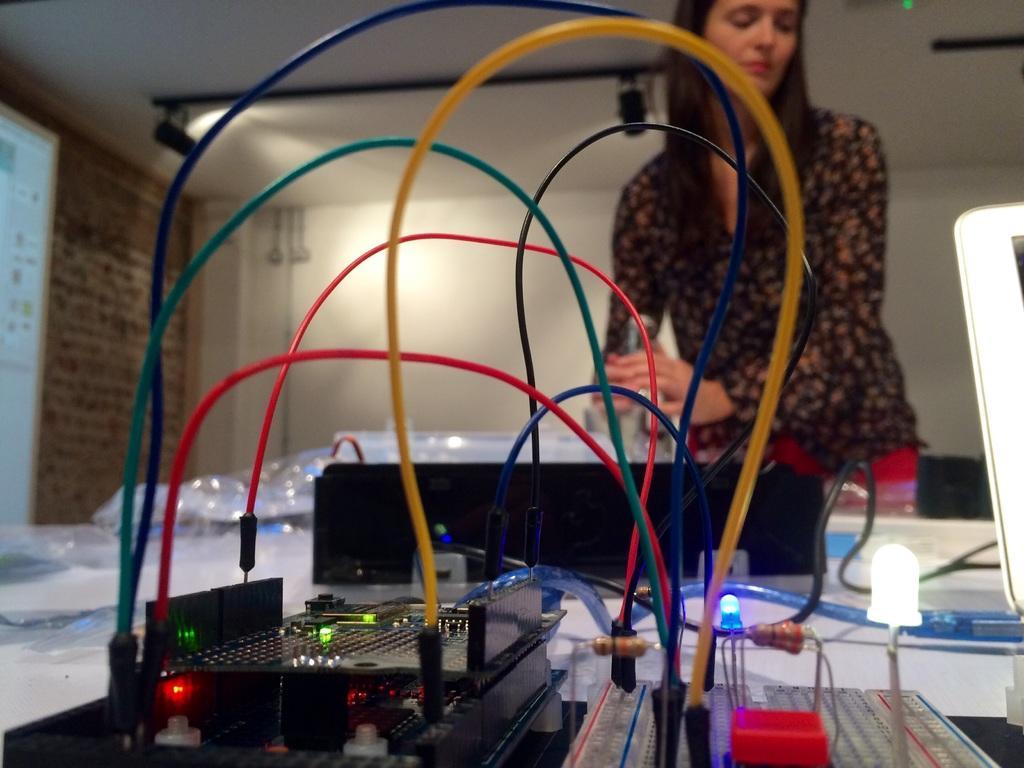In one or two sentences, can you explain what this image depicts? In this image, we can see a person wearing clothes. There is an electrical equipment at the bottom of the image. There is a screen on the left side of the image. 